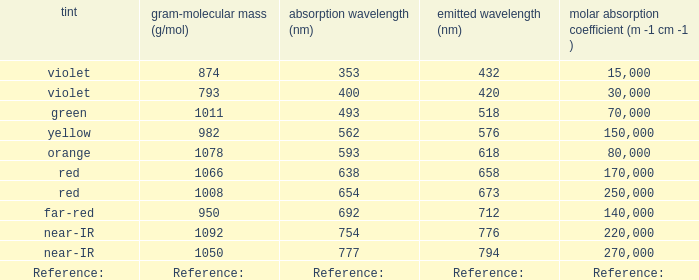Which Emission (in nanometers) has an absorbtion of 593 nm? 618.0. 